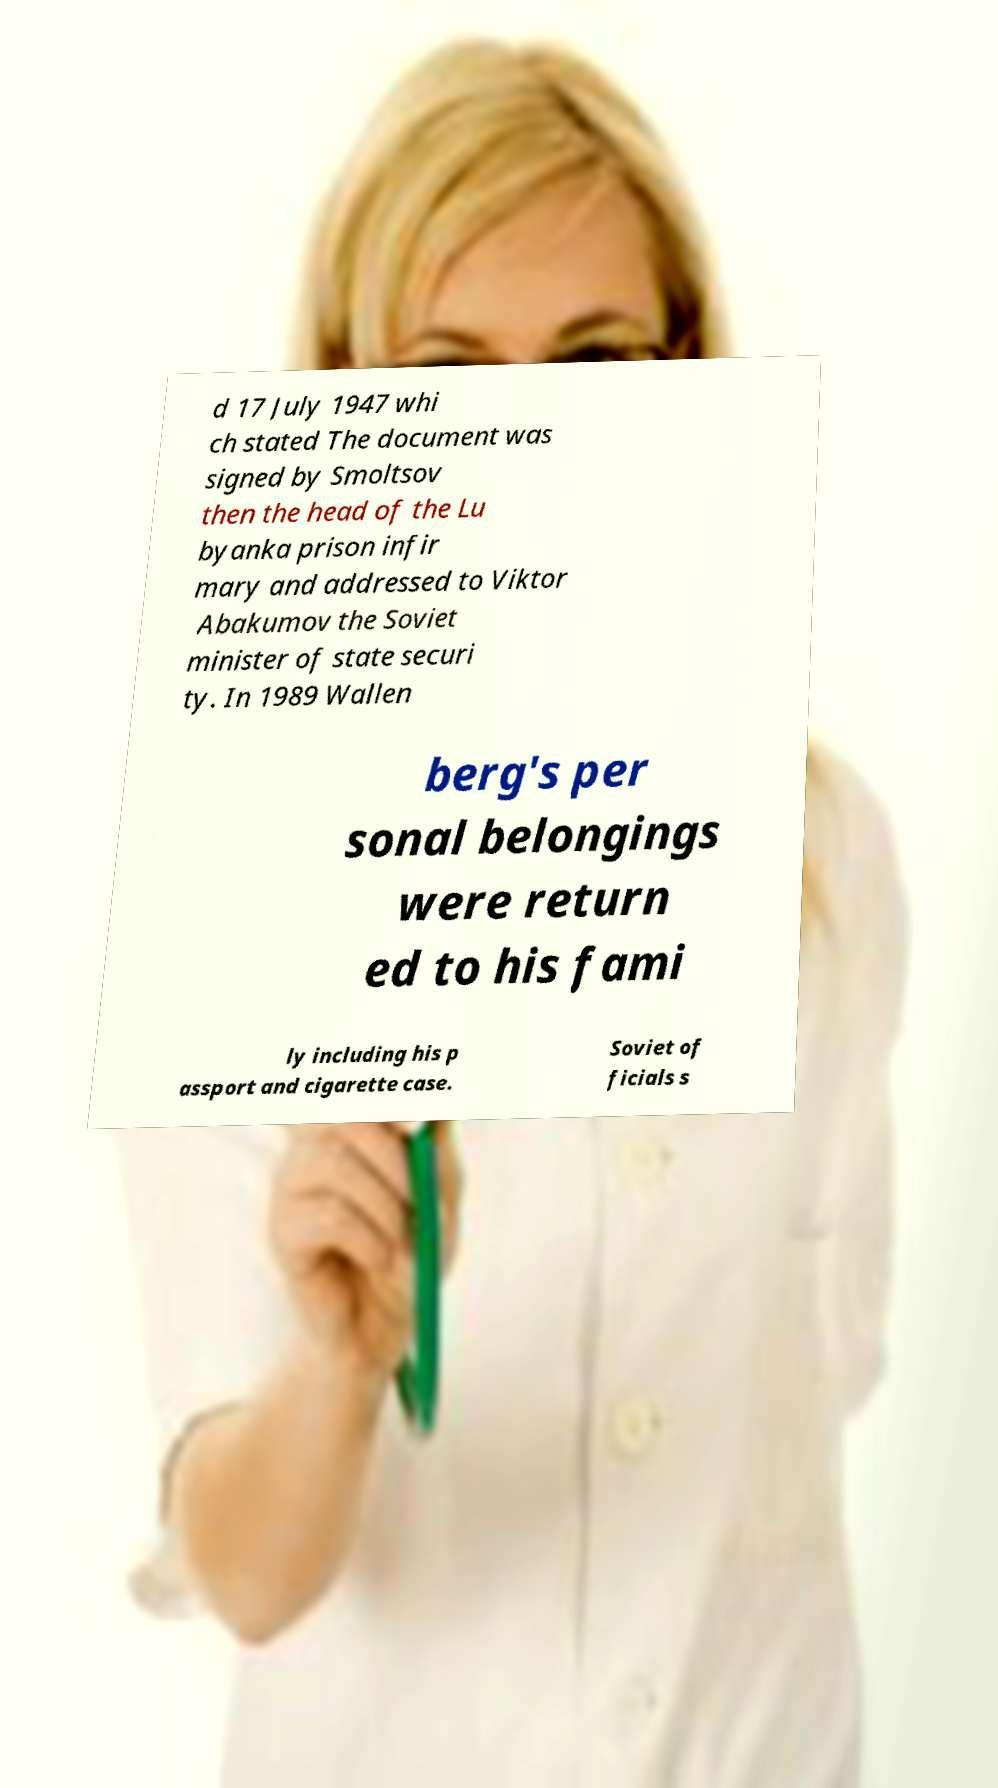I need the written content from this picture converted into text. Can you do that? d 17 July 1947 whi ch stated The document was signed by Smoltsov then the head of the Lu byanka prison infir mary and addressed to Viktor Abakumov the Soviet minister of state securi ty. In 1989 Wallen berg's per sonal belongings were return ed to his fami ly including his p assport and cigarette case. Soviet of ficials s 